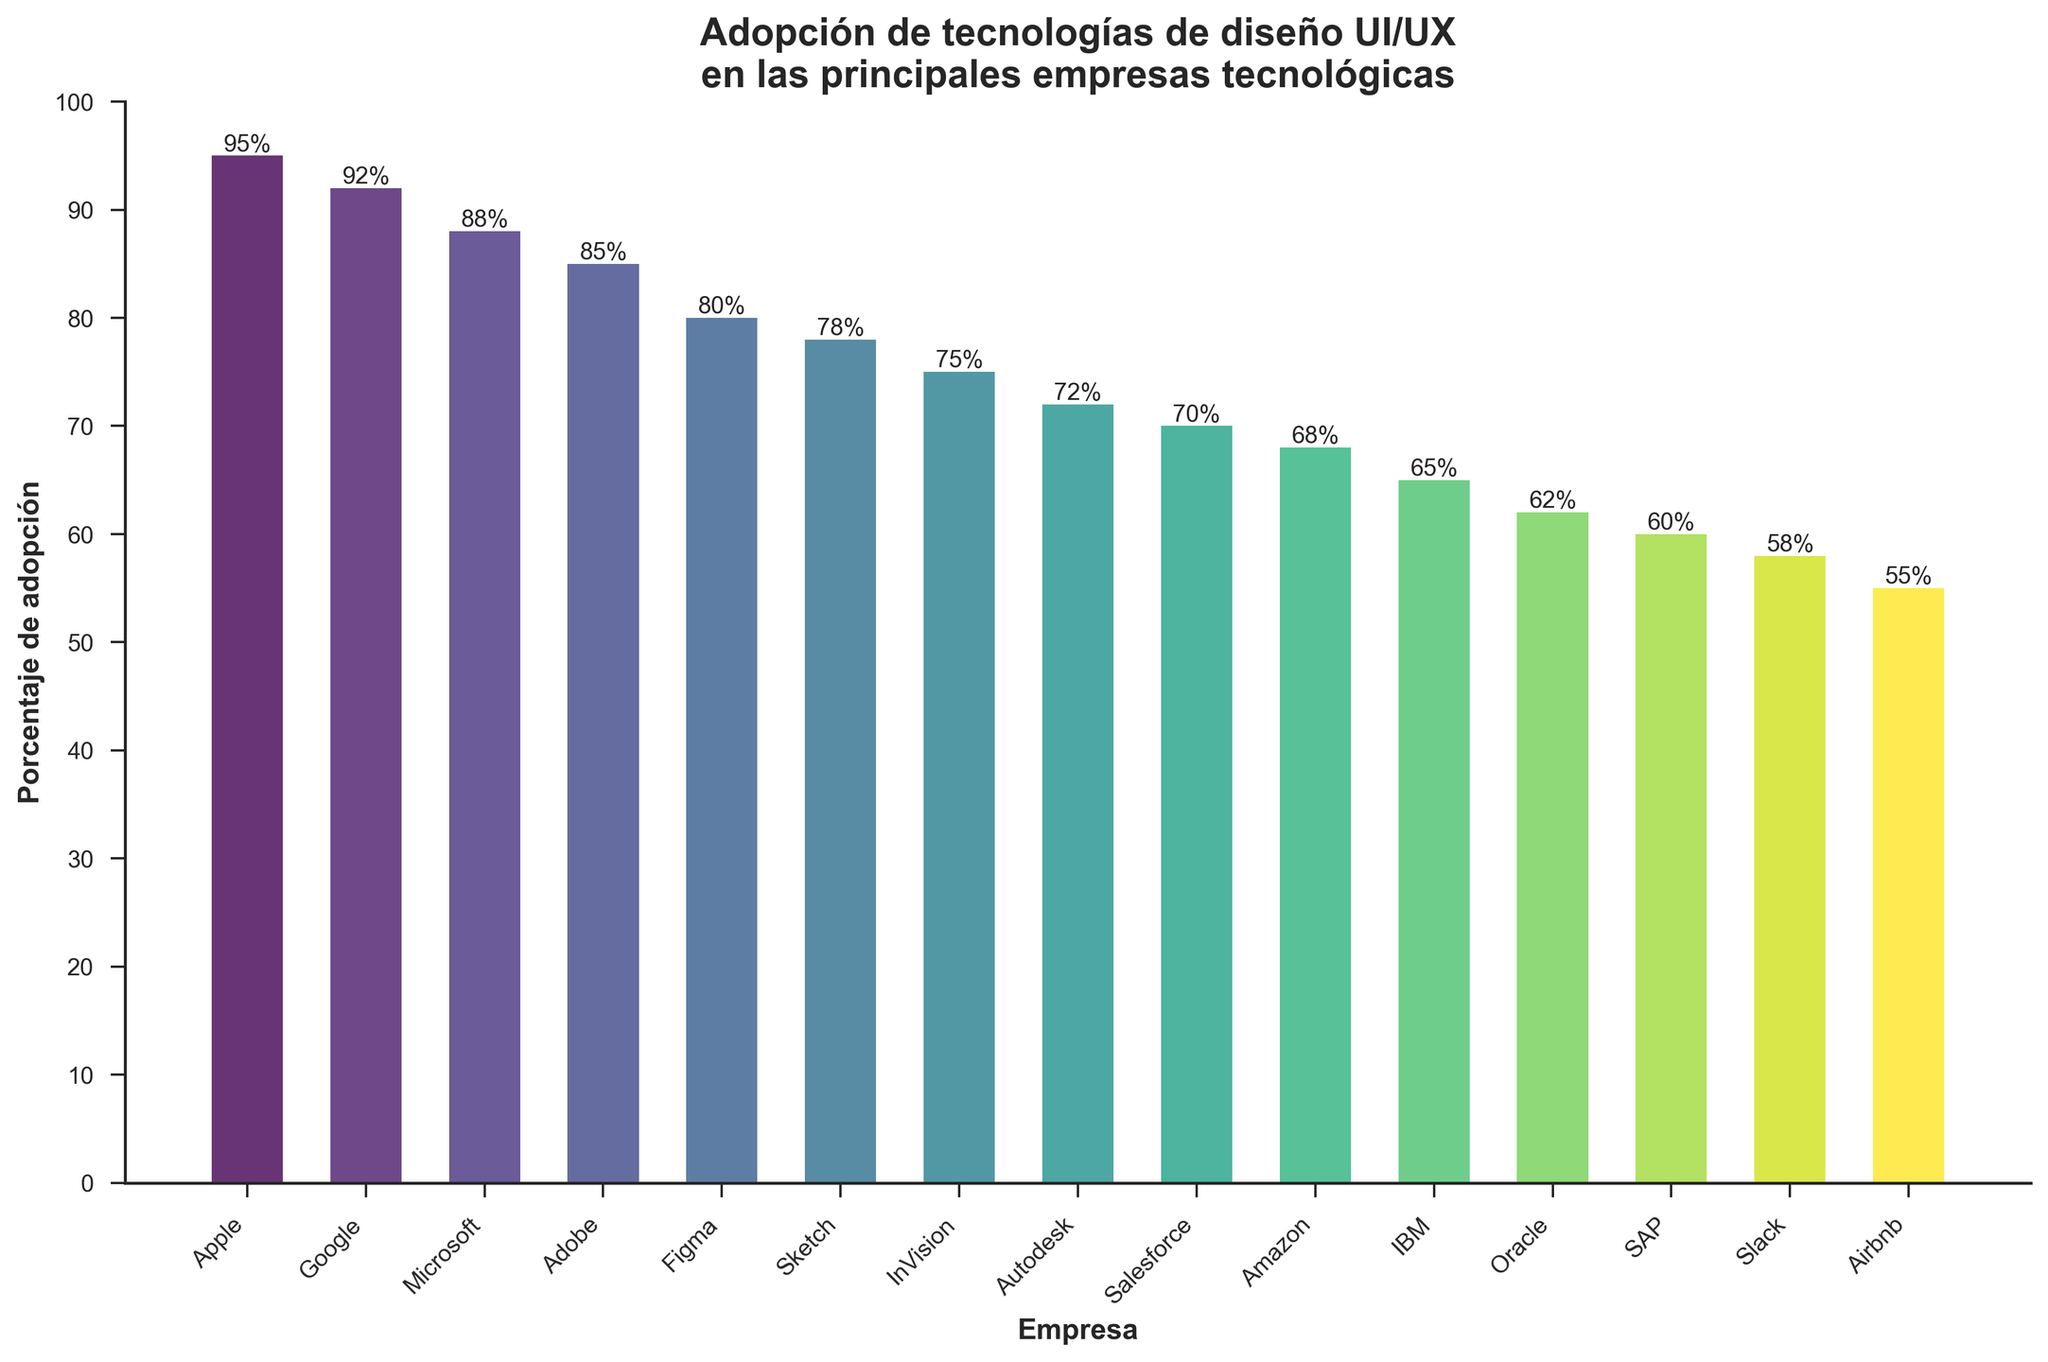¿Cuál es la empresa con el mayor porcentaje de adopción de tecnologías de diseño UI/UX? La barra más alta en la gráfica corresponde a Apple, con un porcentaje de adopción de 95%.
Answer: Apple ¿Cuáles empresas tienen un porcentaje de adopción mayor al 80%? Las barras que superan el 80% de adopción corresponden a Apple, Google, Microsoft, Adobe, y Figma, con porcentajes de 95%, 92%, 88%, 85%, y 80% respectivamente.
Answer: Apple, Google, Microsoft, Adobe, Figma ¿Cuál es la diferencia en el porcentaje de adopción entre Apple y Amazon? Apple tiene un porcentaje de adopción del 95%, mientras que Amazon tiene 68%. La diferencia es 95% - 68% = 27%.
Answer: 27% ¿Cuál es el rango de porcentajes de adopción que se observa en la gráfica? El porcentaje más alto es de Apple con un 95% y el más bajo es de Airbnb con un 55%. El rango es 95% - 55% = 40%.
Answer: 40% ¿Cuántas empresas tienen un porcentaje de adopción entre 60% y 80% inclusivos? Las empresas que están entre 60% y 80% son Figma, Sketch, InVision, Autodesk, Salesforce, Amazon, e IBM, sumando un total de 7 empresas.
Answer: 7 ¿Qué empresa tiene un porcentaje de adopción más cercano al promedio de todas las empresas? Primero, calculamos el promedio sumando todos los porcentajes (95 + 92 + 88 + 85 + 80 + 78 + 75 + 72 + 70 + 68 + 65 + 62 + 60 + 58 + 55 = 1103) y dividiéndolos por 15, obteniendo un promedio aproximado de 73.5%. Autodesk, con 72%, es la empresa con un porcentaje más cercano a este promedio.
Answer: Autodesk ¿Cuál es el porcentaje total de adopción combinado de las tres empresas con menor adopción? Las tres empresas con menor adopción son Airbnb (55%), Slack (58%), y SAP (60%). Sumando estos porcentajes 55% + 58% + 60% = 173%.
Answer: 173% ¿Cuál es el segundo color más oscuro usado en la gráfica y qué empresa representa? En la gráfica, los colores van de más oscuro a más claro desde la primera barra (Apple) a la última (Airbnb). El segundo color más oscuro representa a Google con un 92% de adopción.
Answer: Google 